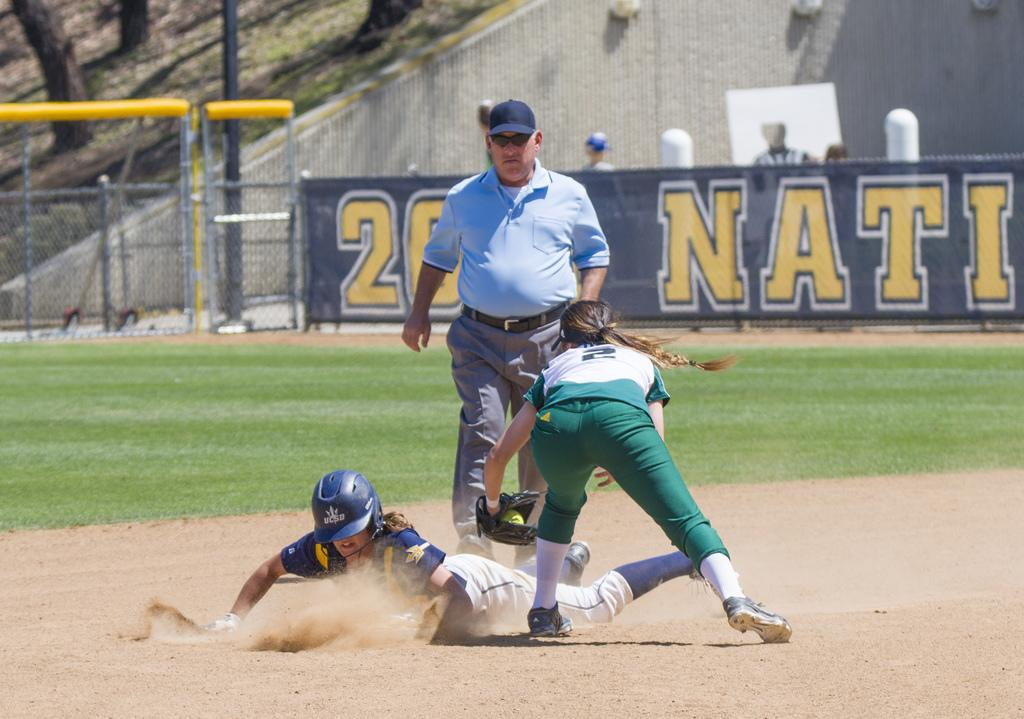<image>
Create a compact narrative representing the image presented. Player 2 tries to tag the sliding player at the base. 